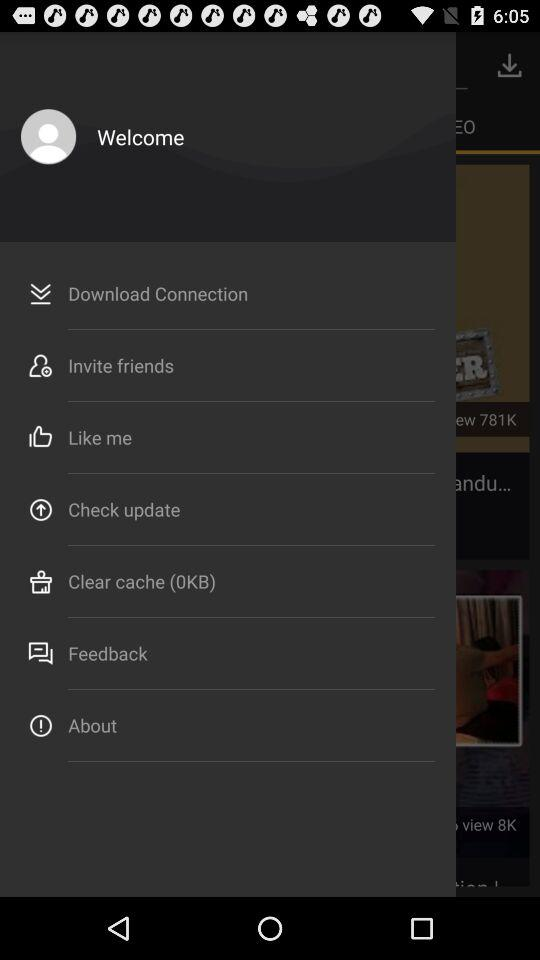How many KB are in the "Clear cache"? There is 0 KB in the "Clear cache". 